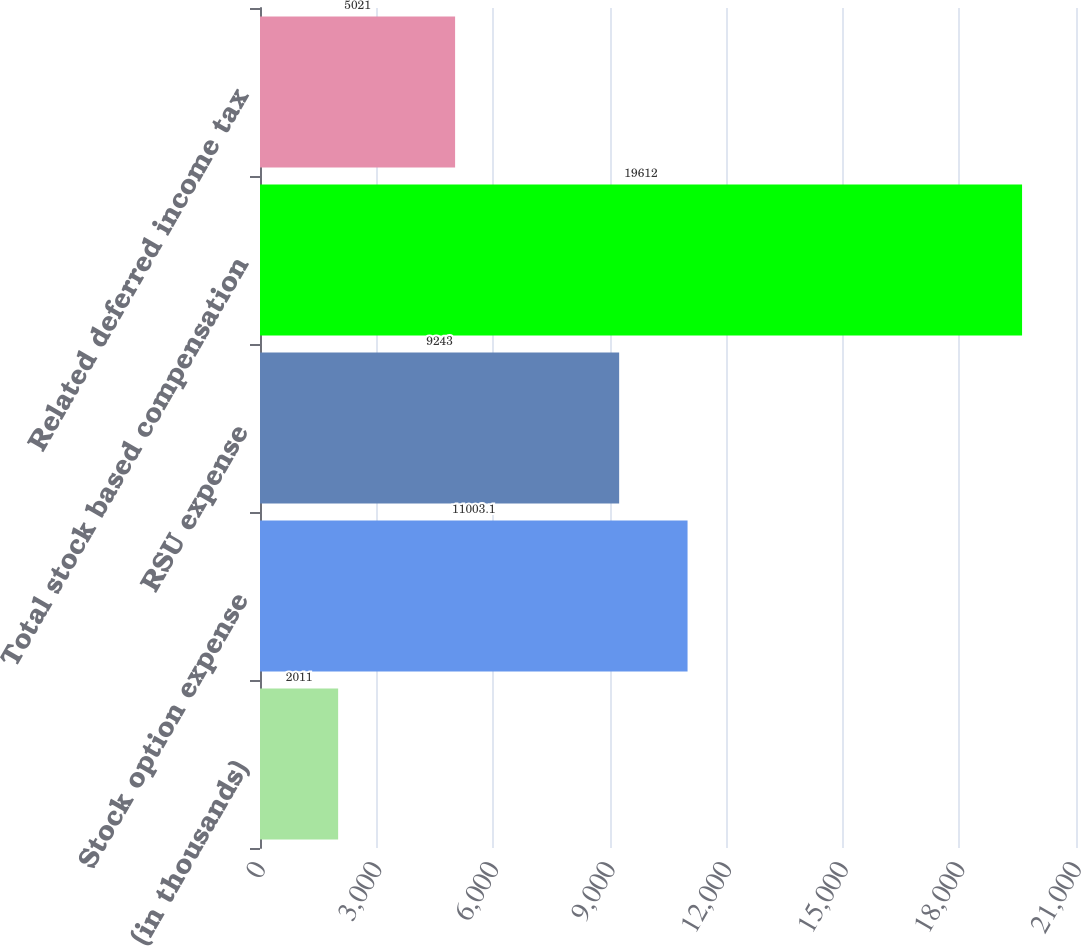Convert chart to OTSL. <chart><loc_0><loc_0><loc_500><loc_500><bar_chart><fcel>(in thousands)<fcel>Stock option expense<fcel>RSU expense<fcel>Total stock based compensation<fcel>Related deferred income tax<nl><fcel>2011<fcel>11003.1<fcel>9243<fcel>19612<fcel>5021<nl></chart> 